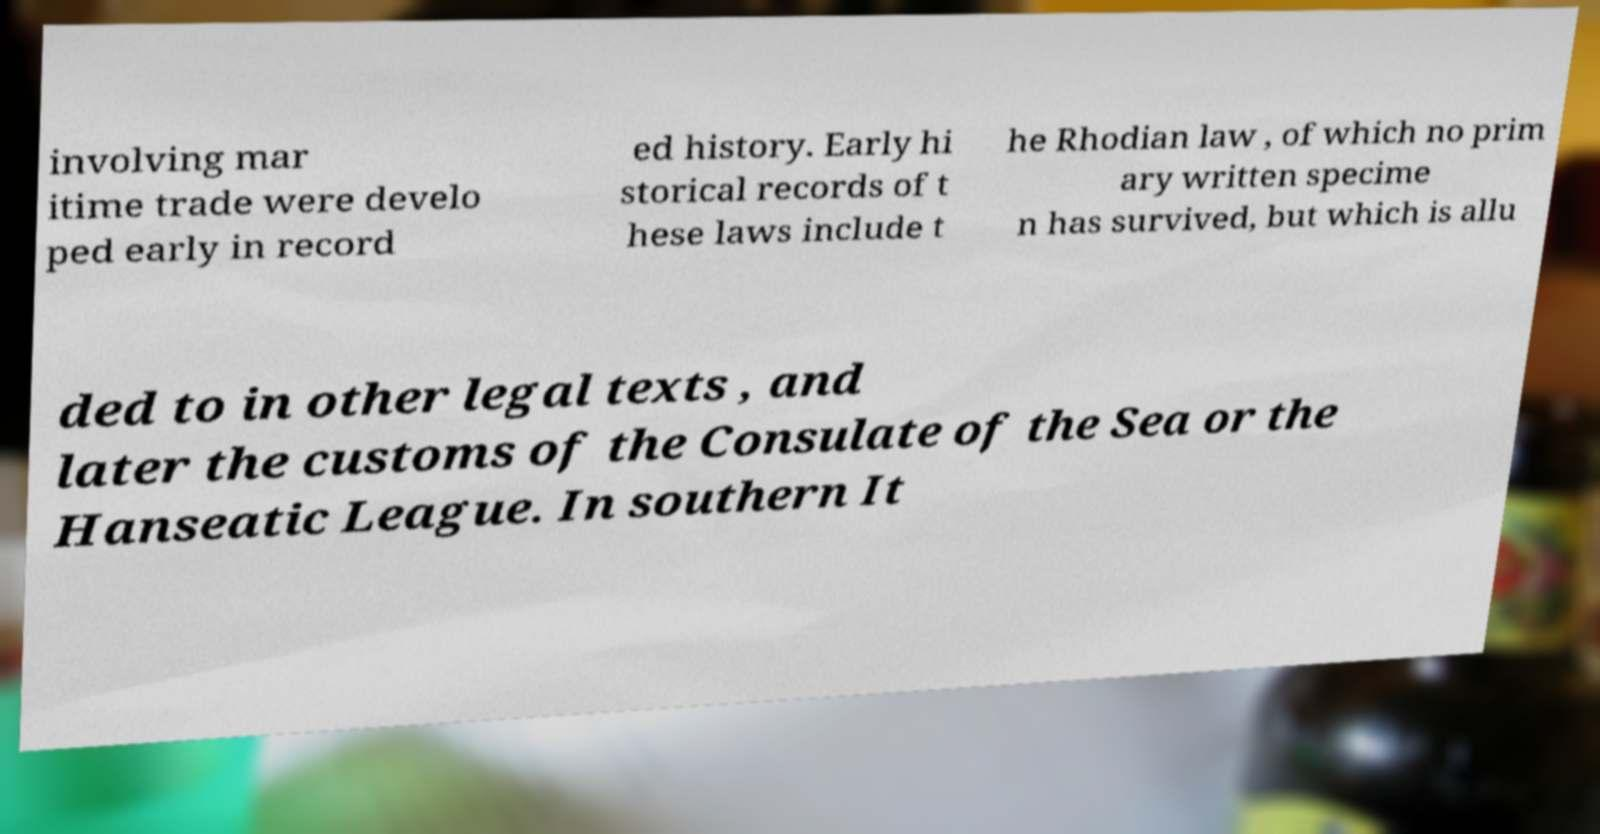Can you accurately transcribe the text from the provided image for me? involving mar itime trade were develo ped early in record ed history. Early hi storical records of t hese laws include t he Rhodian law , of which no prim ary written specime n has survived, but which is allu ded to in other legal texts , and later the customs of the Consulate of the Sea or the Hanseatic League. In southern It 